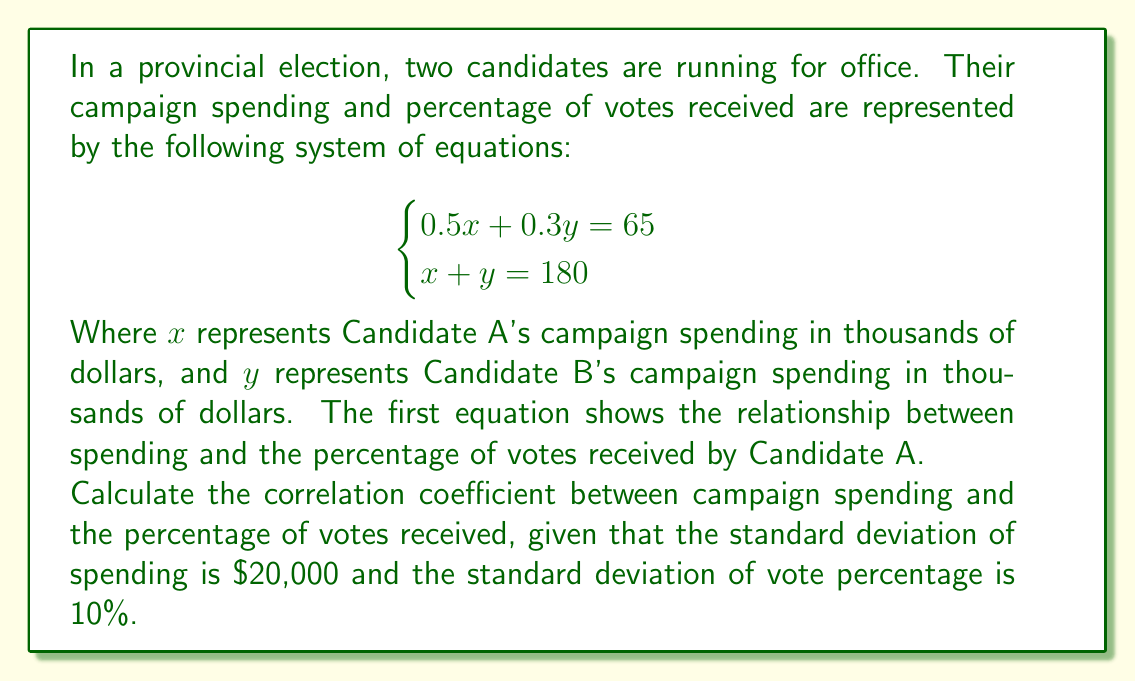Could you help me with this problem? To solve this problem, we'll follow these steps:

1. Solve the system of equations to find x and y.
2. Calculate the covariance between spending and vote percentage.
3. Use the given standard deviations to calculate the correlation coefficient.

Step 1: Solve the system of equations

From the second equation: $y = 180 - x$
Substitute this into the first equation:
$$0.5x + 0.3(180 - x) = 65$$
$$0.5x + 54 - 0.3x = 65$$
$$0.2x = 11$$
$$x = 55$$

Substitute back to find y:
$$y = 180 - 55 = 125$$

So, Candidate A spent $\$55,000$ and Candidate B spent $\$125,000$.

Step 2: Calculate the covariance

The mean spending is $\frac{55 + 125}{2} = 90$ thousand dollars.
The mean vote percentage is $\frac{65 + 35}{2} = 50\%$ (since Candidate A received 65%, Candidate B must have received 35%).

Covariance = $\frac{1}{2}[(55 - 90)(65 - 50) + (125 - 90)(35 - 50)]$
            $= \frac{1}{2}[(-35)(15) + (35)(-15)]$
            $= \frac{1}{2}[-525 - 525]$
            $= -525$

Step 3: Calculate the correlation coefficient

The correlation coefficient $r$ is given by:

$$r = \frac{Cov(X,Y)}{\sigma_X \sigma_Y}$$

Where $Cov(X,Y)$ is the covariance, and $\sigma_X$ and $\sigma_Y$ are the standard deviations of X and Y respectively.

$$r = \frac{-525}{20 \cdot 10} = -\frac{525}{200} = -2.625$$
Answer: The correlation coefficient between campaign spending and percentage of votes received is $-2.625$. 